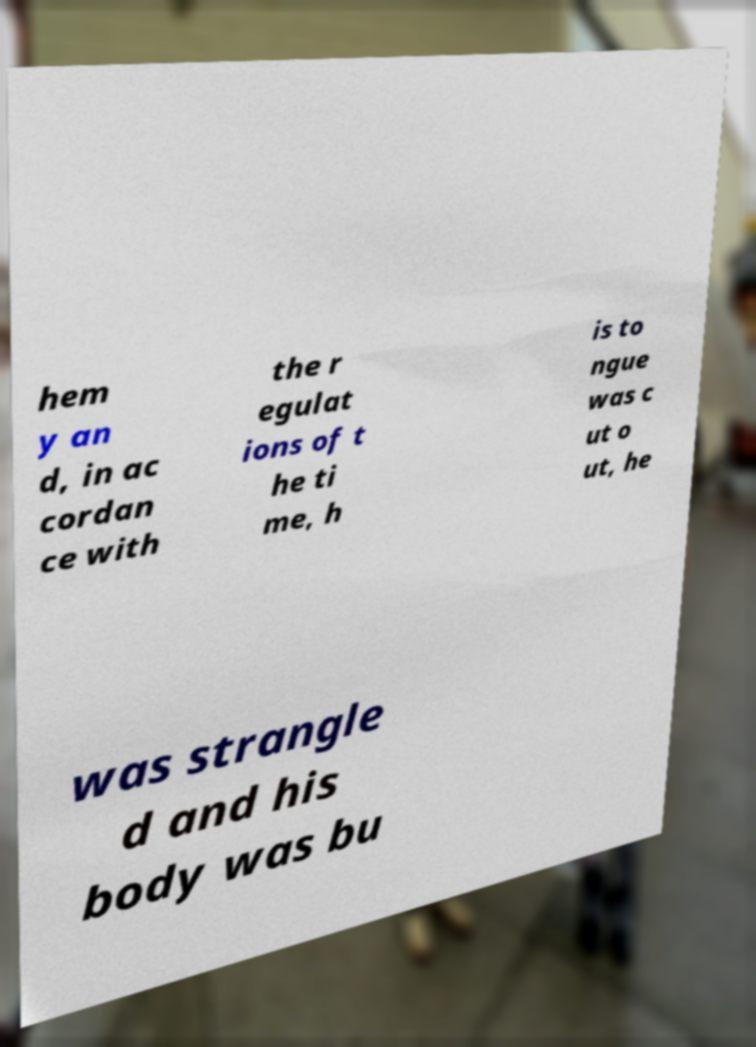For documentation purposes, I need the text within this image transcribed. Could you provide that? hem y an d, in ac cordan ce with the r egulat ions of t he ti me, h is to ngue was c ut o ut, he was strangle d and his body was bu 